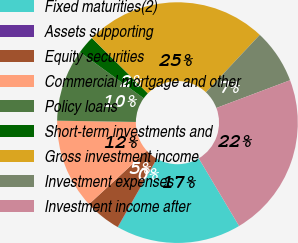<chart> <loc_0><loc_0><loc_500><loc_500><pie_chart><fcel>Fixed maturities(2)<fcel>Assets supporting<fcel>Equity securities<fcel>Commercial mortgage and other<fcel>Policy loans<fcel>Short-term investments and<fcel>Gross investment income<fcel>Investment expenses<fcel>Investment income after<nl><fcel>16.8%<fcel>0.03%<fcel>4.87%<fcel>12.11%<fcel>9.7%<fcel>2.45%<fcel>24.58%<fcel>7.28%<fcel>22.17%<nl></chart> 